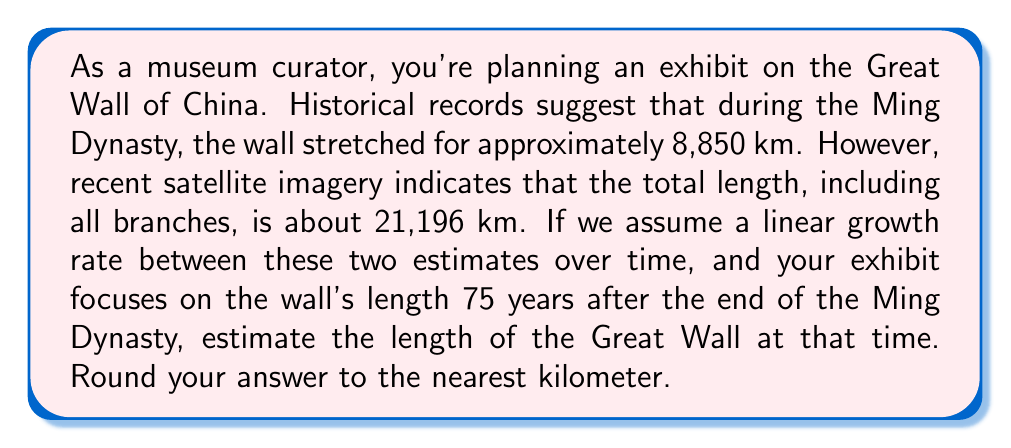Show me your answer to this math problem. Let's approach this step-by-step:

1) First, we need to set up our linear equation. We'll use the slope-intercept form: $y = mx + b$

   Where:
   $y$ is the length of the wall
   $x$ is the time
   $m$ is the slope (rate of change)
   $b$ is the y-intercept (initial length)

2) We know two points:
   $(0, 8850)$ - End of Ming Dynasty
   $(t, 21196)$ - Present day, where $t$ is the time elapsed since the end of Ming Dynasty

3) To find the slope $m$:

   $$m = \frac{y_2 - y_1}{x_2 - x_1} = \frac{21196 - 8850}{t - 0} = \frac{12346}{t}$$

4) Now we can form our equation:

   $$y = \frac{12346}{t}x + 8850$$

5) We want to find the length 75 years after the end of the Ming Dynasty. So we plug in $x = 75$:

   $$y = \frac{12346}{t}(75) + 8850$$

6) We don't know $t$, but we can estimate it. The Ming Dynasty ended in 1644, and the satellite imagery is recent. Let's assume $t = 375$ years.

7) Plugging this in:

   $$y = \frac{12346}{375}(75) + 8850$$

8) Simplifying:

   $$y = 2469.2 + 8850 = 11319.2$$

9) Rounding to the nearest kilometer:

   $$y \approx 11319 \text{ km}$$
Answer: The estimated length of the Great Wall 75 years after the end of the Ming Dynasty is approximately 11,319 km. 